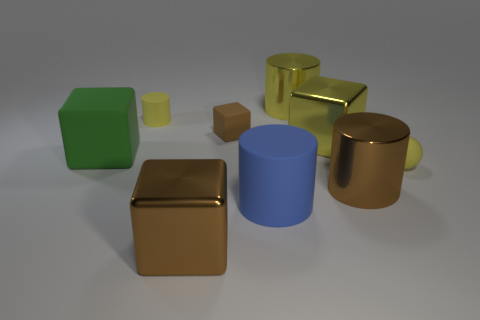Subtract 2 blocks. How many blocks are left? 2 Subtract all gray cubes. Subtract all purple balls. How many cubes are left? 4 Subtract all cylinders. How many objects are left? 5 Add 3 small yellow cylinders. How many small yellow cylinders exist? 4 Subtract 2 yellow cylinders. How many objects are left? 7 Subtract all blue rubber cylinders. Subtract all large brown objects. How many objects are left? 6 Add 8 small brown blocks. How many small brown blocks are left? 9 